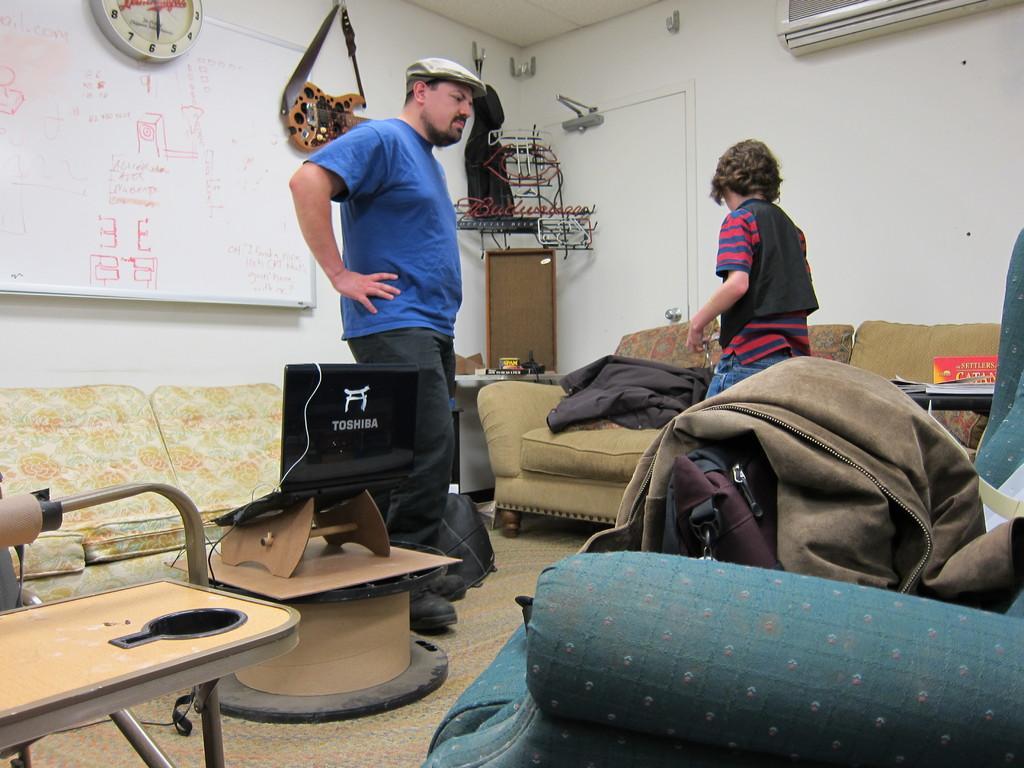Could you give a brief overview of what you see in this image? There are two members in this room. There are some sofa sets on which some clothes were placed. There is a laptop in front of a sofa on the table. There is a wall on which a clock and guitar were hanged. 